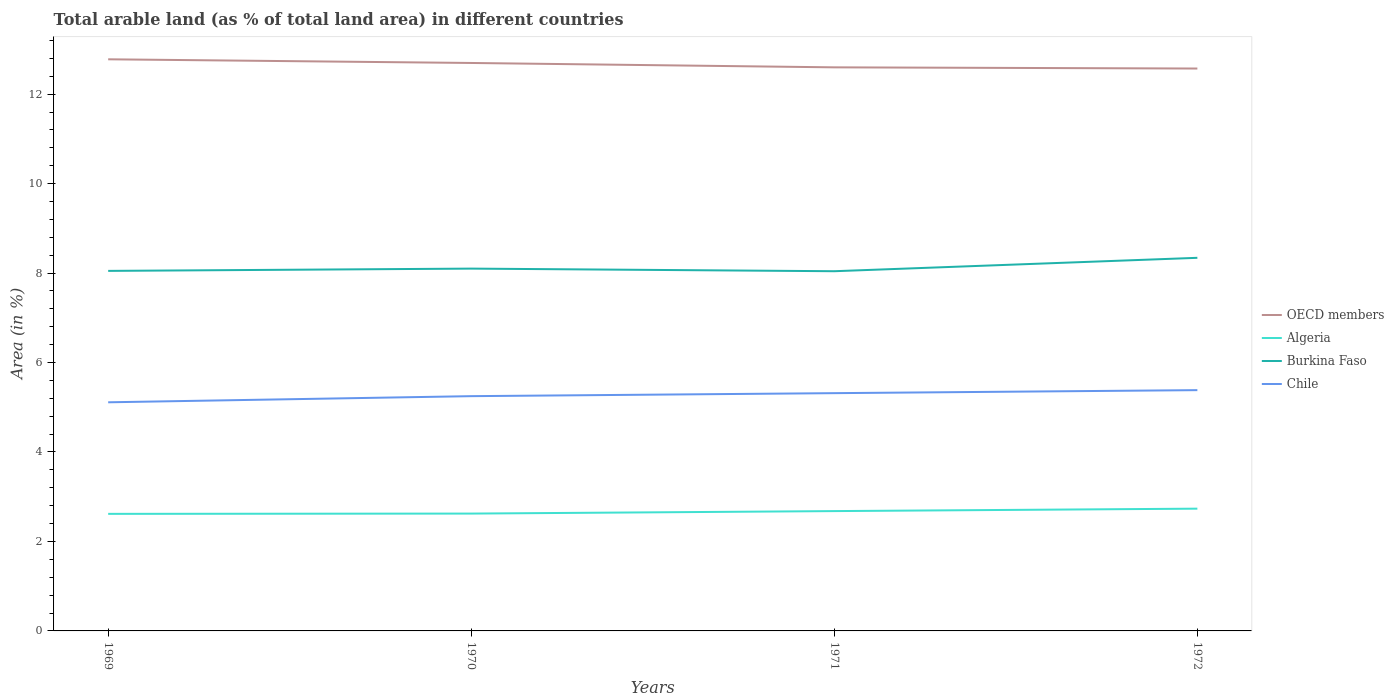Does the line corresponding to Chile intersect with the line corresponding to Algeria?
Provide a short and direct response. No. Is the number of lines equal to the number of legend labels?
Give a very brief answer. Yes. Across all years, what is the maximum percentage of arable land in Chile?
Provide a succinct answer. 5.11. What is the total percentage of arable land in OECD members in the graph?
Provide a succinct answer. 0.21. What is the difference between the highest and the second highest percentage of arable land in Chile?
Keep it short and to the point. 0.27. Is the percentage of arable land in OECD members strictly greater than the percentage of arable land in Burkina Faso over the years?
Your response must be concise. No. What is the title of the graph?
Your answer should be compact. Total arable land (as % of total land area) in different countries. Does "Bulgaria" appear as one of the legend labels in the graph?
Your response must be concise. No. What is the label or title of the Y-axis?
Offer a terse response. Area (in %). What is the Area (in %) of OECD members in 1969?
Keep it short and to the point. 12.78. What is the Area (in %) in Algeria in 1969?
Your answer should be very brief. 2.62. What is the Area (in %) of Burkina Faso in 1969?
Offer a very short reply. 8.05. What is the Area (in %) in Chile in 1969?
Provide a succinct answer. 5.11. What is the Area (in %) of OECD members in 1970?
Your answer should be very brief. 12.7. What is the Area (in %) in Algeria in 1970?
Provide a succinct answer. 2.62. What is the Area (in %) of Burkina Faso in 1970?
Keep it short and to the point. 8.1. What is the Area (in %) in Chile in 1970?
Offer a very short reply. 5.25. What is the Area (in %) in OECD members in 1971?
Ensure brevity in your answer.  12.6. What is the Area (in %) of Algeria in 1971?
Your response must be concise. 2.68. What is the Area (in %) of Burkina Faso in 1971?
Offer a terse response. 8.04. What is the Area (in %) of Chile in 1971?
Your answer should be very brief. 5.32. What is the Area (in %) of OECD members in 1972?
Your response must be concise. 12.57. What is the Area (in %) in Algeria in 1972?
Offer a terse response. 2.73. What is the Area (in %) of Burkina Faso in 1972?
Ensure brevity in your answer.  8.34. What is the Area (in %) in Chile in 1972?
Provide a succinct answer. 5.38. Across all years, what is the maximum Area (in %) in OECD members?
Provide a succinct answer. 12.78. Across all years, what is the maximum Area (in %) in Algeria?
Your response must be concise. 2.73. Across all years, what is the maximum Area (in %) in Burkina Faso?
Make the answer very short. 8.34. Across all years, what is the maximum Area (in %) in Chile?
Offer a terse response. 5.38. Across all years, what is the minimum Area (in %) in OECD members?
Provide a succinct answer. 12.57. Across all years, what is the minimum Area (in %) in Algeria?
Provide a succinct answer. 2.62. Across all years, what is the minimum Area (in %) in Burkina Faso?
Offer a terse response. 8.04. Across all years, what is the minimum Area (in %) of Chile?
Keep it short and to the point. 5.11. What is the total Area (in %) in OECD members in the graph?
Give a very brief answer. 50.65. What is the total Area (in %) in Algeria in the graph?
Make the answer very short. 10.65. What is the total Area (in %) in Burkina Faso in the graph?
Offer a very short reply. 32.53. What is the total Area (in %) of Chile in the graph?
Offer a terse response. 21.06. What is the difference between the Area (in %) of OECD members in 1969 and that in 1970?
Provide a succinct answer. 0.08. What is the difference between the Area (in %) of Algeria in 1969 and that in 1970?
Your response must be concise. -0.01. What is the difference between the Area (in %) in Burkina Faso in 1969 and that in 1970?
Offer a terse response. -0.05. What is the difference between the Area (in %) in Chile in 1969 and that in 1970?
Your response must be concise. -0.14. What is the difference between the Area (in %) in OECD members in 1969 and that in 1971?
Your answer should be compact. 0.18. What is the difference between the Area (in %) of Algeria in 1969 and that in 1971?
Offer a terse response. -0.06. What is the difference between the Area (in %) in Burkina Faso in 1969 and that in 1971?
Keep it short and to the point. 0.01. What is the difference between the Area (in %) in Chile in 1969 and that in 1971?
Ensure brevity in your answer.  -0.2. What is the difference between the Area (in %) in OECD members in 1969 and that in 1972?
Make the answer very short. 0.21. What is the difference between the Area (in %) in Algeria in 1969 and that in 1972?
Your answer should be very brief. -0.12. What is the difference between the Area (in %) in Burkina Faso in 1969 and that in 1972?
Offer a terse response. -0.29. What is the difference between the Area (in %) of Chile in 1969 and that in 1972?
Your response must be concise. -0.27. What is the difference between the Area (in %) of OECD members in 1970 and that in 1971?
Ensure brevity in your answer.  0.1. What is the difference between the Area (in %) of Algeria in 1970 and that in 1971?
Make the answer very short. -0.06. What is the difference between the Area (in %) of Burkina Faso in 1970 and that in 1971?
Make the answer very short. 0.06. What is the difference between the Area (in %) of Chile in 1970 and that in 1971?
Your answer should be very brief. -0.07. What is the difference between the Area (in %) in OECD members in 1970 and that in 1972?
Make the answer very short. 0.12. What is the difference between the Area (in %) of Algeria in 1970 and that in 1972?
Your response must be concise. -0.11. What is the difference between the Area (in %) of Burkina Faso in 1970 and that in 1972?
Ensure brevity in your answer.  -0.24. What is the difference between the Area (in %) in Chile in 1970 and that in 1972?
Keep it short and to the point. -0.13. What is the difference between the Area (in %) of OECD members in 1971 and that in 1972?
Provide a succinct answer. 0.03. What is the difference between the Area (in %) in Algeria in 1971 and that in 1972?
Keep it short and to the point. -0.05. What is the difference between the Area (in %) in Burkina Faso in 1971 and that in 1972?
Offer a very short reply. -0.3. What is the difference between the Area (in %) in Chile in 1971 and that in 1972?
Offer a terse response. -0.07. What is the difference between the Area (in %) of OECD members in 1969 and the Area (in %) of Algeria in 1970?
Offer a very short reply. 10.15. What is the difference between the Area (in %) in OECD members in 1969 and the Area (in %) in Burkina Faso in 1970?
Ensure brevity in your answer.  4.68. What is the difference between the Area (in %) in OECD members in 1969 and the Area (in %) in Chile in 1970?
Your answer should be very brief. 7.53. What is the difference between the Area (in %) in Algeria in 1969 and the Area (in %) in Burkina Faso in 1970?
Offer a terse response. -5.48. What is the difference between the Area (in %) in Algeria in 1969 and the Area (in %) in Chile in 1970?
Ensure brevity in your answer.  -2.63. What is the difference between the Area (in %) in Burkina Faso in 1969 and the Area (in %) in Chile in 1970?
Offer a terse response. 2.8. What is the difference between the Area (in %) in OECD members in 1969 and the Area (in %) in Algeria in 1971?
Make the answer very short. 10.1. What is the difference between the Area (in %) in OECD members in 1969 and the Area (in %) in Burkina Faso in 1971?
Ensure brevity in your answer.  4.74. What is the difference between the Area (in %) of OECD members in 1969 and the Area (in %) of Chile in 1971?
Your answer should be very brief. 7.46. What is the difference between the Area (in %) in Algeria in 1969 and the Area (in %) in Burkina Faso in 1971?
Your answer should be very brief. -5.42. What is the difference between the Area (in %) of Algeria in 1969 and the Area (in %) of Chile in 1971?
Offer a terse response. -2.7. What is the difference between the Area (in %) of Burkina Faso in 1969 and the Area (in %) of Chile in 1971?
Keep it short and to the point. 2.73. What is the difference between the Area (in %) of OECD members in 1969 and the Area (in %) of Algeria in 1972?
Provide a short and direct response. 10.04. What is the difference between the Area (in %) in OECD members in 1969 and the Area (in %) in Burkina Faso in 1972?
Your response must be concise. 4.44. What is the difference between the Area (in %) in OECD members in 1969 and the Area (in %) in Chile in 1972?
Offer a very short reply. 7.4. What is the difference between the Area (in %) of Algeria in 1969 and the Area (in %) of Burkina Faso in 1972?
Your answer should be very brief. -5.72. What is the difference between the Area (in %) of Algeria in 1969 and the Area (in %) of Chile in 1972?
Your answer should be very brief. -2.77. What is the difference between the Area (in %) in Burkina Faso in 1969 and the Area (in %) in Chile in 1972?
Provide a succinct answer. 2.67. What is the difference between the Area (in %) in OECD members in 1970 and the Area (in %) in Algeria in 1971?
Make the answer very short. 10.02. What is the difference between the Area (in %) of OECD members in 1970 and the Area (in %) of Burkina Faso in 1971?
Ensure brevity in your answer.  4.66. What is the difference between the Area (in %) in OECD members in 1970 and the Area (in %) in Chile in 1971?
Provide a succinct answer. 7.38. What is the difference between the Area (in %) in Algeria in 1970 and the Area (in %) in Burkina Faso in 1971?
Give a very brief answer. -5.42. What is the difference between the Area (in %) in Algeria in 1970 and the Area (in %) in Chile in 1971?
Make the answer very short. -2.69. What is the difference between the Area (in %) of Burkina Faso in 1970 and the Area (in %) of Chile in 1971?
Provide a succinct answer. 2.78. What is the difference between the Area (in %) of OECD members in 1970 and the Area (in %) of Algeria in 1972?
Provide a succinct answer. 9.96. What is the difference between the Area (in %) of OECD members in 1970 and the Area (in %) of Burkina Faso in 1972?
Your answer should be very brief. 4.36. What is the difference between the Area (in %) of OECD members in 1970 and the Area (in %) of Chile in 1972?
Offer a very short reply. 7.31. What is the difference between the Area (in %) of Algeria in 1970 and the Area (in %) of Burkina Faso in 1972?
Offer a terse response. -5.72. What is the difference between the Area (in %) in Algeria in 1970 and the Area (in %) in Chile in 1972?
Provide a succinct answer. -2.76. What is the difference between the Area (in %) of Burkina Faso in 1970 and the Area (in %) of Chile in 1972?
Keep it short and to the point. 2.72. What is the difference between the Area (in %) of OECD members in 1971 and the Area (in %) of Algeria in 1972?
Make the answer very short. 9.87. What is the difference between the Area (in %) in OECD members in 1971 and the Area (in %) in Burkina Faso in 1972?
Keep it short and to the point. 4.26. What is the difference between the Area (in %) in OECD members in 1971 and the Area (in %) in Chile in 1972?
Provide a short and direct response. 7.22. What is the difference between the Area (in %) of Algeria in 1971 and the Area (in %) of Burkina Faso in 1972?
Your answer should be very brief. -5.66. What is the difference between the Area (in %) of Algeria in 1971 and the Area (in %) of Chile in 1972?
Your answer should be very brief. -2.7. What is the difference between the Area (in %) of Burkina Faso in 1971 and the Area (in %) of Chile in 1972?
Give a very brief answer. 2.66. What is the average Area (in %) of OECD members per year?
Provide a succinct answer. 12.66. What is the average Area (in %) in Algeria per year?
Make the answer very short. 2.66. What is the average Area (in %) of Burkina Faso per year?
Your answer should be compact. 8.13. What is the average Area (in %) in Chile per year?
Offer a terse response. 5.26. In the year 1969, what is the difference between the Area (in %) of OECD members and Area (in %) of Algeria?
Offer a terse response. 10.16. In the year 1969, what is the difference between the Area (in %) in OECD members and Area (in %) in Burkina Faso?
Your response must be concise. 4.73. In the year 1969, what is the difference between the Area (in %) of OECD members and Area (in %) of Chile?
Your answer should be very brief. 7.67. In the year 1969, what is the difference between the Area (in %) of Algeria and Area (in %) of Burkina Faso?
Your response must be concise. -5.43. In the year 1969, what is the difference between the Area (in %) in Algeria and Area (in %) in Chile?
Make the answer very short. -2.49. In the year 1969, what is the difference between the Area (in %) of Burkina Faso and Area (in %) of Chile?
Your answer should be very brief. 2.94. In the year 1970, what is the difference between the Area (in %) in OECD members and Area (in %) in Algeria?
Your response must be concise. 10.07. In the year 1970, what is the difference between the Area (in %) in OECD members and Area (in %) in Burkina Faso?
Keep it short and to the point. 4.6. In the year 1970, what is the difference between the Area (in %) of OECD members and Area (in %) of Chile?
Make the answer very short. 7.45. In the year 1970, what is the difference between the Area (in %) of Algeria and Area (in %) of Burkina Faso?
Your response must be concise. -5.48. In the year 1970, what is the difference between the Area (in %) of Algeria and Area (in %) of Chile?
Give a very brief answer. -2.62. In the year 1970, what is the difference between the Area (in %) of Burkina Faso and Area (in %) of Chile?
Ensure brevity in your answer.  2.85. In the year 1971, what is the difference between the Area (in %) in OECD members and Area (in %) in Algeria?
Ensure brevity in your answer.  9.92. In the year 1971, what is the difference between the Area (in %) in OECD members and Area (in %) in Burkina Faso?
Keep it short and to the point. 4.56. In the year 1971, what is the difference between the Area (in %) in OECD members and Area (in %) in Chile?
Your answer should be very brief. 7.28. In the year 1971, what is the difference between the Area (in %) of Algeria and Area (in %) of Burkina Faso?
Your answer should be very brief. -5.36. In the year 1971, what is the difference between the Area (in %) in Algeria and Area (in %) in Chile?
Provide a short and direct response. -2.64. In the year 1971, what is the difference between the Area (in %) in Burkina Faso and Area (in %) in Chile?
Make the answer very short. 2.73. In the year 1972, what is the difference between the Area (in %) of OECD members and Area (in %) of Algeria?
Keep it short and to the point. 9.84. In the year 1972, what is the difference between the Area (in %) of OECD members and Area (in %) of Burkina Faso?
Your answer should be compact. 4.23. In the year 1972, what is the difference between the Area (in %) in OECD members and Area (in %) in Chile?
Your answer should be very brief. 7.19. In the year 1972, what is the difference between the Area (in %) of Algeria and Area (in %) of Burkina Faso?
Your response must be concise. -5.61. In the year 1972, what is the difference between the Area (in %) of Algeria and Area (in %) of Chile?
Offer a terse response. -2.65. In the year 1972, what is the difference between the Area (in %) of Burkina Faso and Area (in %) of Chile?
Give a very brief answer. 2.96. What is the ratio of the Area (in %) in OECD members in 1969 to that in 1970?
Your answer should be compact. 1.01. What is the ratio of the Area (in %) in Algeria in 1969 to that in 1970?
Provide a succinct answer. 1. What is the ratio of the Area (in %) of Burkina Faso in 1969 to that in 1970?
Make the answer very short. 0.99. What is the ratio of the Area (in %) in Chile in 1969 to that in 1970?
Offer a very short reply. 0.97. What is the ratio of the Area (in %) in OECD members in 1969 to that in 1971?
Provide a short and direct response. 1.01. What is the ratio of the Area (in %) of Chile in 1969 to that in 1971?
Provide a short and direct response. 0.96. What is the ratio of the Area (in %) of OECD members in 1969 to that in 1972?
Provide a succinct answer. 1.02. What is the ratio of the Area (in %) in Algeria in 1969 to that in 1972?
Keep it short and to the point. 0.96. What is the ratio of the Area (in %) of Burkina Faso in 1969 to that in 1972?
Make the answer very short. 0.96. What is the ratio of the Area (in %) of Chile in 1969 to that in 1972?
Make the answer very short. 0.95. What is the ratio of the Area (in %) of OECD members in 1970 to that in 1971?
Offer a very short reply. 1.01. What is the ratio of the Area (in %) in Algeria in 1970 to that in 1971?
Make the answer very short. 0.98. What is the ratio of the Area (in %) in Burkina Faso in 1970 to that in 1971?
Your answer should be very brief. 1.01. What is the ratio of the Area (in %) of Chile in 1970 to that in 1971?
Keep it short and to the point. 0.99. What is the ratio of the Area (in %) of OECD members in 1970 to that in 1972?
Ensure brevity in your answer.  1.01. What is the ratio of the Area (in %) of Algeria in 1970 to that in 1972?
Make the answer very short. 0.96. What is the ratio of the Area (in %) of Burkina Faso in 1970 to that in 1972?
Your answer should be compact. 0.97. What is the ratio of the Area (in %) of OECD members in 1971 to that in 1972?
Provide a short and direct response. 1. What is the ratio of the Area (in %) of Burkina Faso in 1971 to that in 1972?
Offer a terse response. 0.96. What is the ratio of the Area (in %) of Chile in 1971 to that in 1972?
Make the answer very short. 0.99. What is the difference between the highest and the second highest Area (in %) in OECD members?
Offer a very short reply. 0.08. What is the difference between the highest and the second highest Area (in %) of Algeria?
Ensure brevity in your answer.  0.05. What is the difference between the highest and the second highest Area (in %) of Burkina Faso?
Provide a short and direct response. 0.24. What is the difference between the highest and the second highest Area (in %) in Chile?
Offer a terse response. 0.07. What is the difference between the highest and the lowest Area (in %) in OECD members?
Your answer should be very brief. 0.21. What is the difference between the highest and the lowest Area (in %) of Algeria?
Offer a terse response. 0.12. What is the difference between the highest and the lowest Area (in %) in Burkina Faso?
Provide a succinct answer. 0.3. What is the difference between the highest and the lowest Area (in %) in Chile?
Provide a short and direct response. 0.27. 